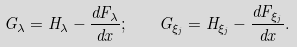Convert formula to latex. <formula><loc_0><loc_0><loc_500><loc_500>G _ { \lambda } = H _ { \lambda } - \frac { d F _ { \lambda } } { d x } ; \quad G _ { \xi _ { j } } = H _ { \xi _ { j } } - \frac { d F _ { \xi _ { j } } } { d x } .</formula> 